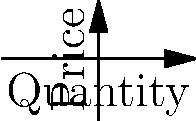In perfect competition, firms maximize profit at the point where marginal cost (MC) equals marginal revenue (MR). Based on the graph, at what quantity does the firm maximize its profit, and what is the corresponding price? To determine the profit-maximizing quantity and price in perfect competition:

1. Identify the intersection point of MC and MR curves:
   The MC curve (blue) intersects the MR curve (red) at point A.

2. Find the quantity at the intersection:
   The x-coordinate of point A represents the profit-maximizing quantity.
   From the graph, we can see this occurs at a quantity of 5 units.

3. Determine the price:
   In perfect competition, price equals marginal revenue.
   The y-coordinate of point A (which is on the MR line) gives us the price.
   The price at point A is 10.

4. Verify the profit-maximization condition:
   At point A, MC = MR = Price, satisfying the condition for profit maximization in perfect competition.

Therefore, the firm maximizes its profit by producing 5 units at a price of 10.
Answer: Quantity: 5, Price: 10 